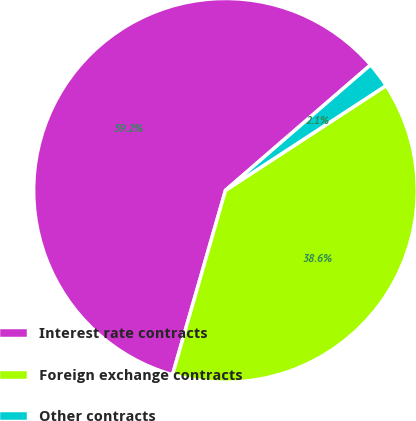Convert chart. <chart><loc_0><loc_0><loc_500><loc_500><pie_chart><fcel>Interest rate contracts<fcel>Foreign exchange contracts<fcel>Other contracts<nl><fcel>59.2%<fcel>38.65%<fcel>2.15%<nl></chart> 